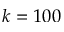Convert formula to latex. <formula><loc_0><loc_0><loc_500><loc_500>k = 1 0 0</formula> 